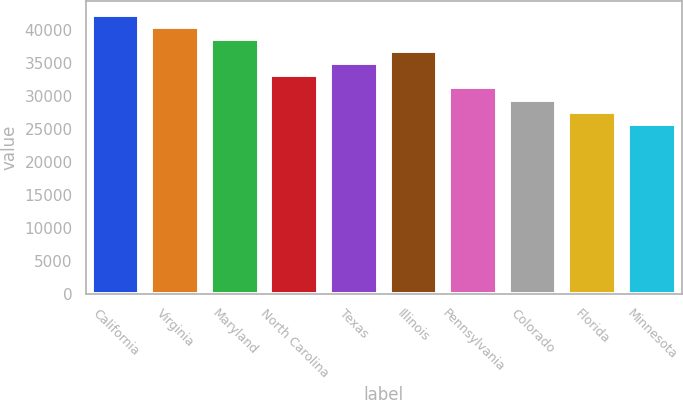<chart> <loc_0><loc_0><loc_500><loc_500><bar_chart><fcel>California<fcel>Virginia<fcel>Maryland<fcel>North Carolina<fcel>Texas<fcel>Illinois<fcel>Pennsylvania<fcel>Colorado<fcel>Florida<fcel>Minnesota<nl><fcel>42265.7<fcel>40429.8<fcel>38593.9<fcel>33086.2<fcel>34922.1<fcel>36758<fcel>31250.3<fcel>29414.4<fcel>27578.5<fcel>25742.6<nl></chart> 